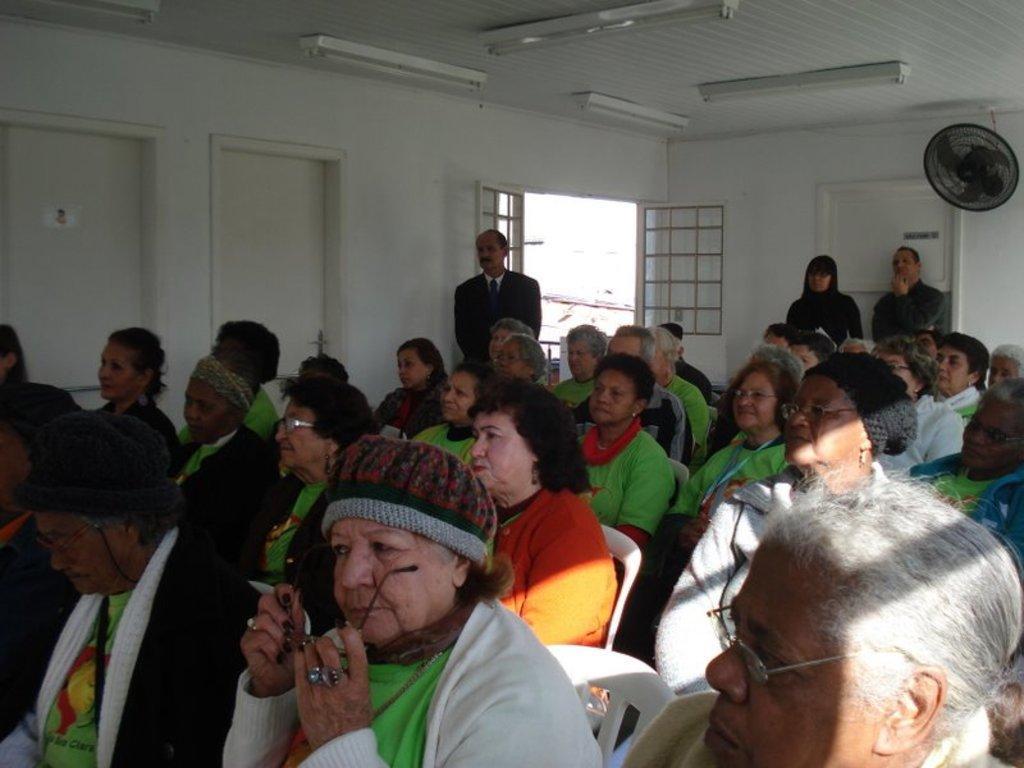Could you give a brief overview of what you see in this image? In this image there are many people sitting on chairs. In the background three people are standing. This is the door. On the ceiling there are lights. Here there is a fan. 